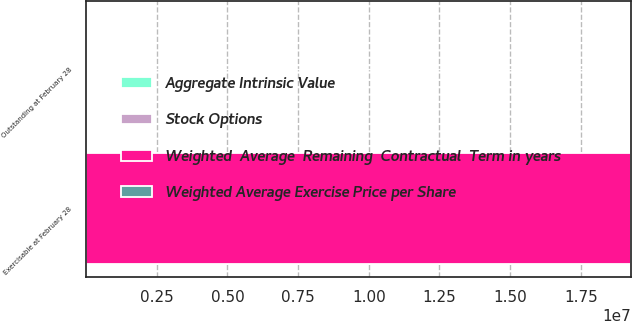Convert chart to OTSL. <chart><loc_0><loc_0><loc_500><loc_500><stacked_bar_chart><ecel><fcel>Outstanding at February 28<fcel>Exercisable at February 28<nl><fcel>Weighted  Average  Remaining  Contractual  Term in years<fcel>33<fcel>1.9277e+07<nl><fcel>Aggregate Intrinsic Value<fcel>38.37<fcel>37.31<nl><fcel>Stock Options<fcel>6.8<fcel>4.6<nl><fcel>Weighted Average Exercise Price per Share<fcel>33<fcel>22<nl></chart> 